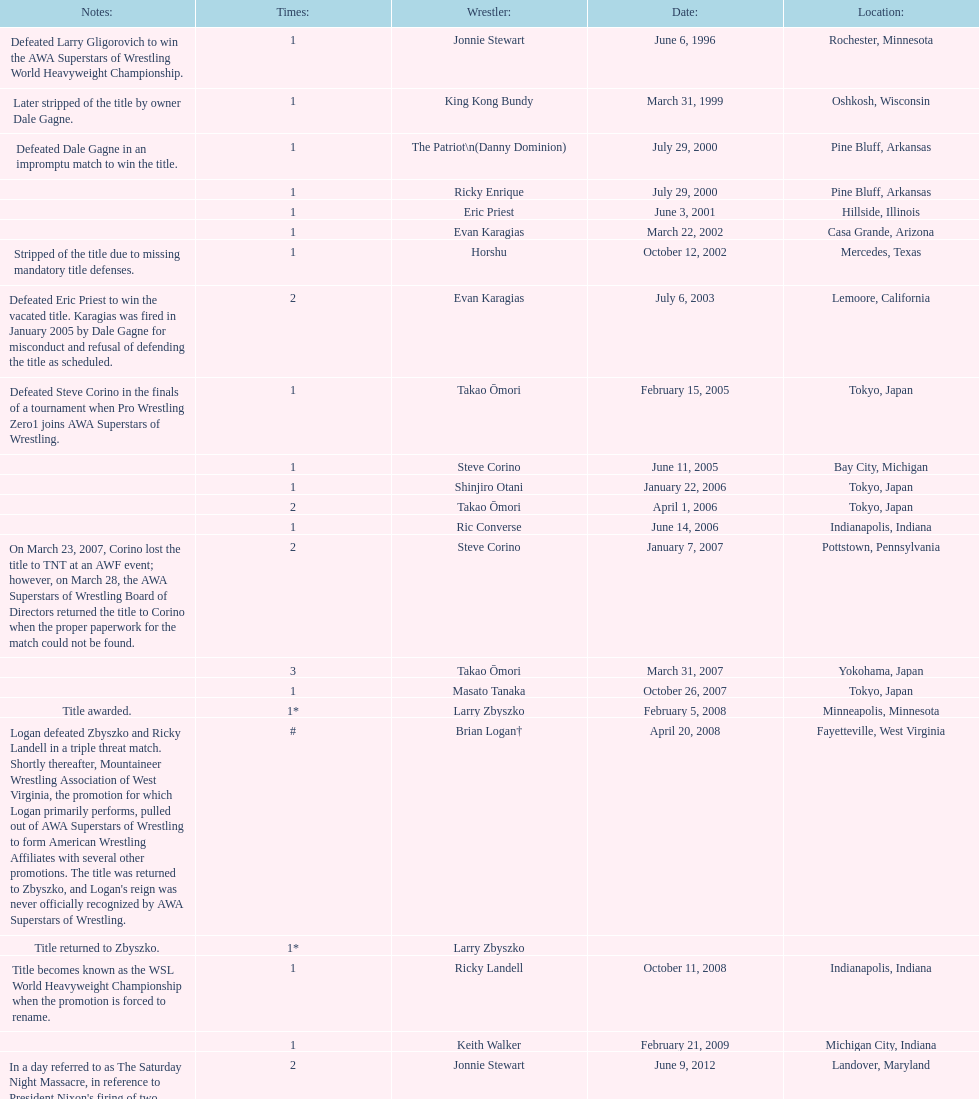How many different men held the wsl title before horshu won his first wsl title? 6. 